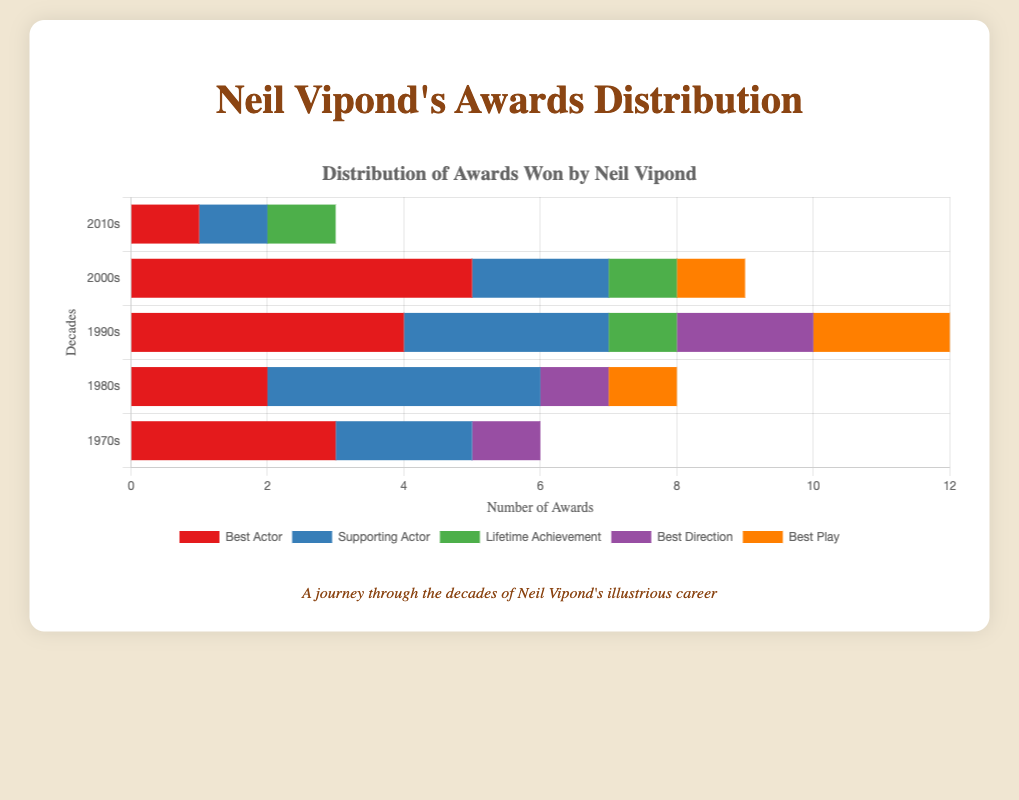Which award category did Neil Vipond win the most in the 2000s? By looking at the stacked bar representing the 2000s, identify the tallest segment. The tallest segment is the red one, corresponding to the "Best Actor" category.
Answer: Best Actor In which decade did Neil Vipond win the most awards for Best Play? Review the lengths of the segments labeled as Best Play (orange) for each decade. The longest segment is in the 1990s.
Answer: 1990s In which category did Neil Vipond win exactly 2 awards in the 1980s? Examine the stacked bars for the 1980s and identify which segments have a length representing 2 awards. The blue segment for Supporting Actor is the correct category.
Answer: Best Play Compare the number of Best Actor awards won by Neil Vipond in the 1990s and the 2010s, which is higher? Check the length of the red segments for the 1990s and 2010s. Neil won 4 Best Actor awards in the 1990s and 1 in the 2010s.
Answer: 1990s What is the total number of awards won by Neil Vipond in the 1970s? Sum up the lengths of all segments for the 1970s: 3 (Best Actor) + 2 (Supporting Actor) + 0 (Lifetime Achievement) + 1 (Best Direction) + 0 (Best Play) = 6
Answer: 6 Between Supporting Actor and Lifetime Achievement, which award did Neil Vipond win more in the 2000s? Compare the lengths of the blue (Supporting Actor) and green (Lifetime Achievement) segments for the 2000s. Supporting Actor is 2 while Lifetime Achievement is 1.
Answer: Supporting Actor What is the combined total of Best Direction awards won in the 1980s and 1990s? Add the number of Best Direction awards from the 1980s and 1990s: 1 (1980s) + 2 (1990s) = 3
Answer: 3 Which category did Neil Vipond win in every decade shown? Look for the award categories present in all bars of each decade. The red segments (Best Actor) appear in every decade.
Answer: Best Actor How many Lifetime Achievement awards has Neil Vipond won in total? Add up all the Lifetime Achievement awards (green segments) over the decades: 0 (1970s) + 0 (1980s) + 1 (1990s) + 1 (2000s) + 1 (2010s) = 3
Answer: 3 What is the difference in the number of Supporting Actor awards won in the 1980s compared to the 2000s? Subtract the Supporting Actor awards in the 2000s from those in the 1980s: 4 (1980s) - 2 (2000s) = 2
Answer: 2 